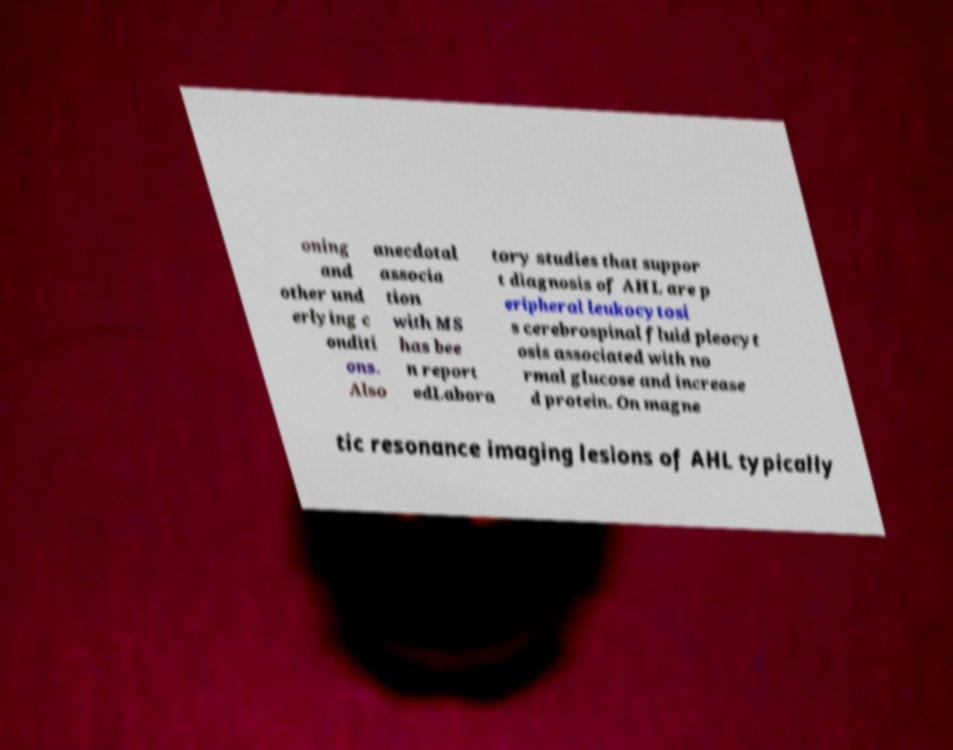For documentation purposes, I need the text within this image transcribed. Could you provide that? oning and other und erlying c onditi ons. Also anecdotal associa tion with MS has bee n report edLabora tory studies that suppor t diagnosis of AHL are p eripheral leukocytosi s cerebrospinal fluid pleocyt osis associated with no rmal glucose and increase d protein. On magne tic resonance imaging lesions of AHL typically 